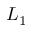Convert formula to latex. <formula><loc_0><loc_0><loc_500><loc_500>L _ { 1 }</formula> 